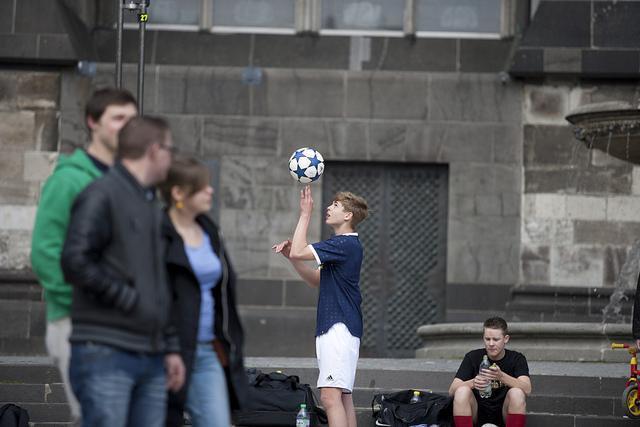How many people are in the photo?
Give a very brief answer. 5. How many animals have a bird on their back?
Give a very brief answer. 0. 